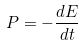Convert formula to latex. <formula><loc_0><loc_0><loc_500><loc_500>P = - \frac { d E } { d t }</formula> 